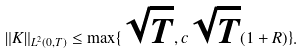Convert formula to latex. <formula><loc_0><loc_0><loc_500><loc_500>\| K \| _ { L ^ { 2 } ( 0 , T ) } \leq \max \{ \sqrt { T } , c \sqrt { T } ( 1 + R ) \} .</formula> 